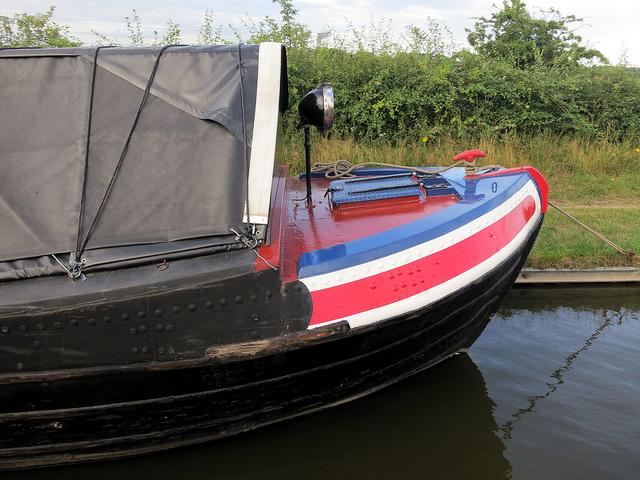Is the boat moored, or is it at sea?
Give a very brief answer. Moored. Why might a large beacon light be stationed onboard this boat?
Concise answer only. To search. What color is the boat?
Concise answer only. Red white and blue. 